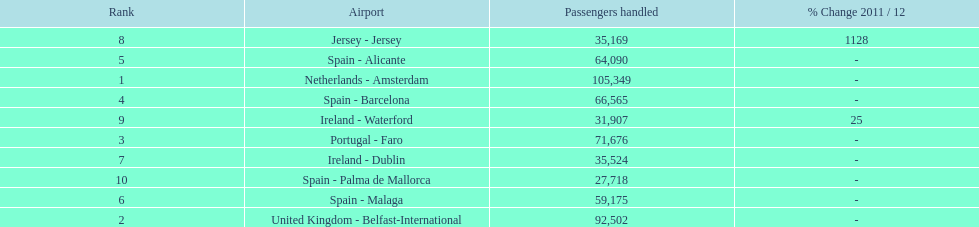Between the topped ranked airport, netherlands - amsterdam, & spain - palma de mallorca, what is the difference in the amount of passengers handled? 77,631. 